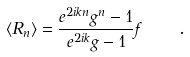<formula> <loc_0><loc_0><loc_500><loc_500>\langle R _ { n } \rangle = \frac { e ^ { 2 i k n } g ^ { n } - 1 } { e ^ { 2 i k } g - 1 } f \quad .</formula> 